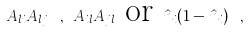Convert formula to latex. <formula><loc_0><loc_0><loc_500><loc_500>\cdots A _ { l i } A _ { l j } \cdots , \cdots A _ { i l } A _ { j l } \cdots \text {or} \cdots \hat { n } _ { i } ( 1 - \hat { n } _ { i } ) \cdots ,</formula> 